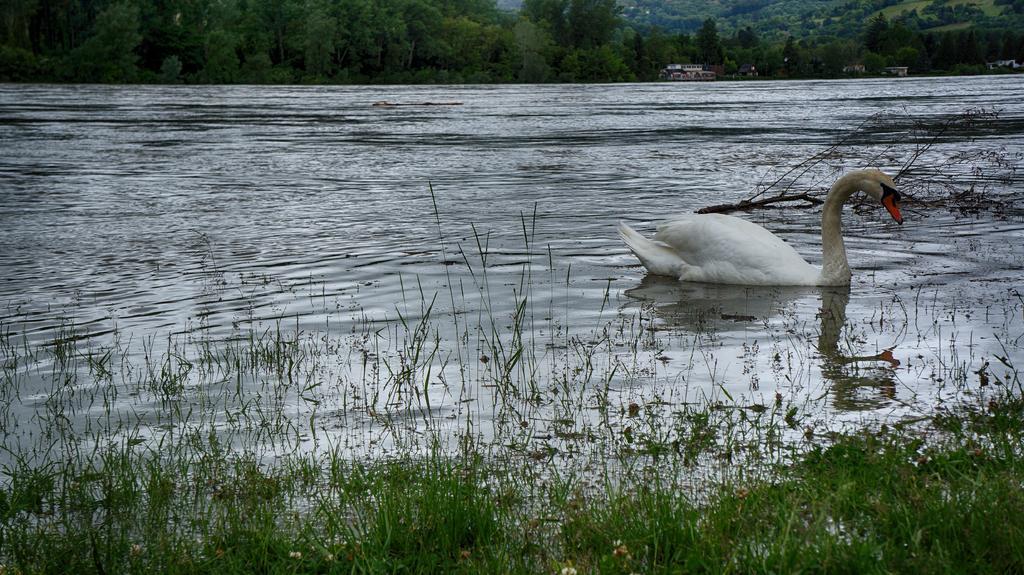Please provide a concise description of this image. In this image, we can see a swan on the water and some part of it is covered with grass. In the background, there are trees and we can see some sheds. 